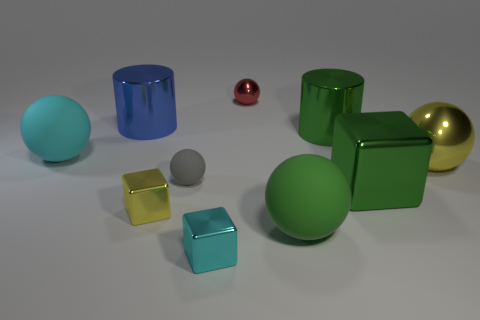There is a cyan metallic object; does it have the same size as the ball right of the green ball?
Provide a succinct answer. No. What color is the big rubber thing behind the big yellow metallic sphere?
Give a very brief answer. Cyan. There is a big matte thing that is the same color as the large metallic cube; what shape is it?
Your answer should be compact. Sphere. The big matte object on the right side of the blue shiny object has what shape?
Offer a very short reply. Sphere. How many yellow things are either cubes or tiny matte objects?
Provide a short and direct response. 1. Is the red ball made of the same material as the green cylinder?
Give a very brief answer. Yes. There is a large yellow shiny object; what number of large cyan rubber balls are left of it?
Offer a terse response. 1. There is a big green object that is in front of the gray sphere and right of the large green rubber ball; what material is it made of?
Your answer should be compact. Metal. What number of balls are either small yellow metal things or green rubber objects?
Give a very brief answer. 1. What is the material of the gray object that is the same shape as the small red object?
Make the answer very short. Rubber. 